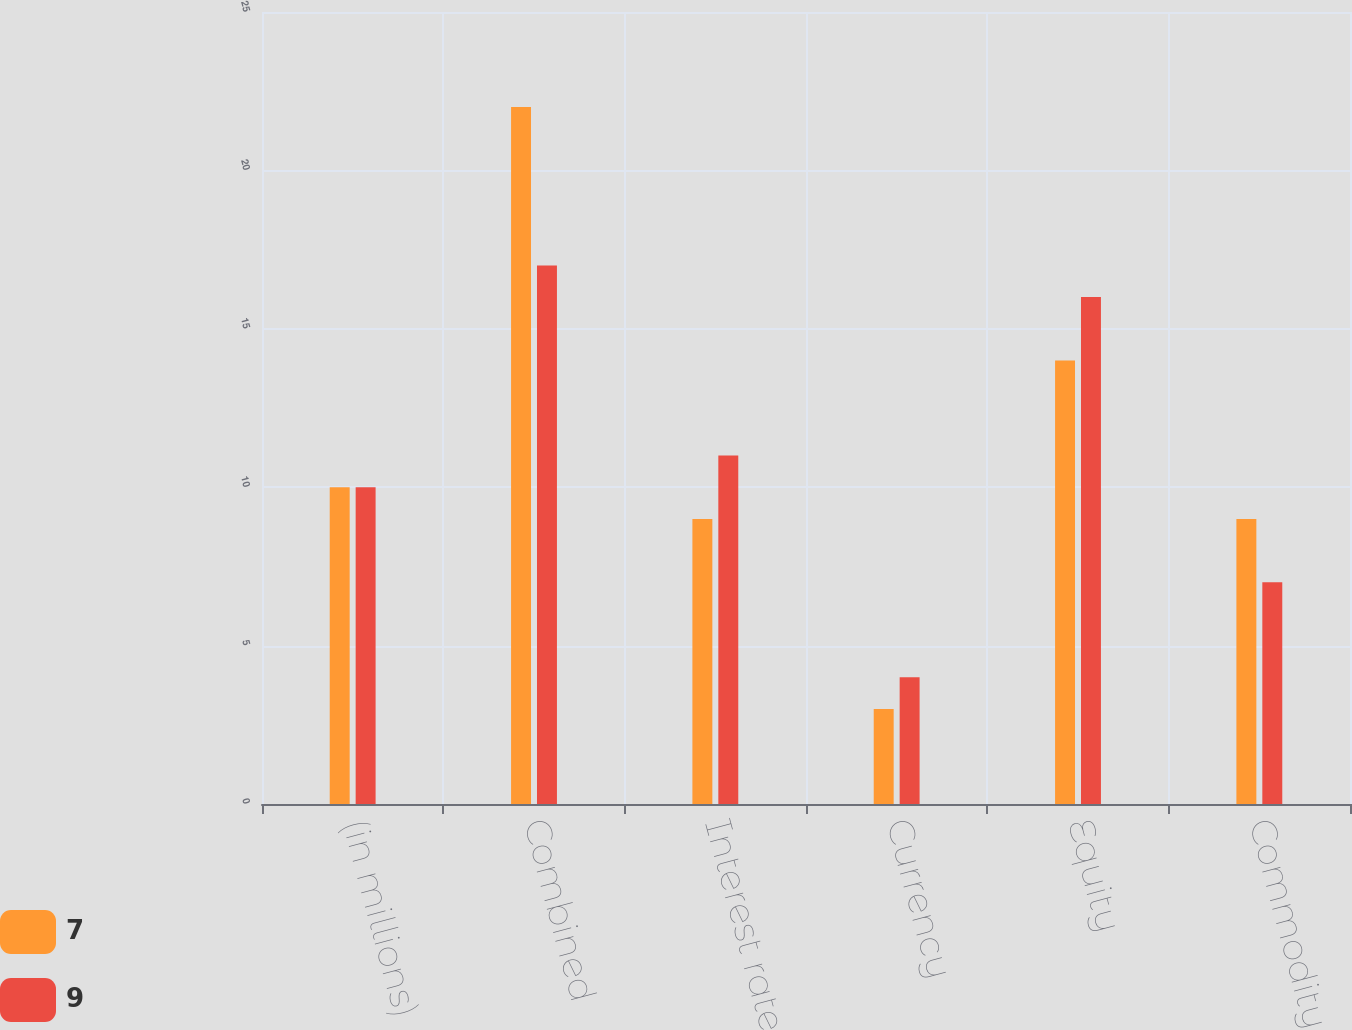Convert chart. <chart><loc_0><loc_0><loc_500><loc_500><stacked_bar_chart><ecel><fcel>(in millions)<fcel>Combined<fcel>Interest rate<fcel>Currency<fcel>Equity<fcel>Commodity<nl><fcel>7<fcel>10<fcel>22<fcel>9<fcel>3<fcel>14<fcel>9<nl><fcel>9<fcel>10<fcel>17<fcel>11<fcel>4<fcel>16<fcel>7<nl></chart> 